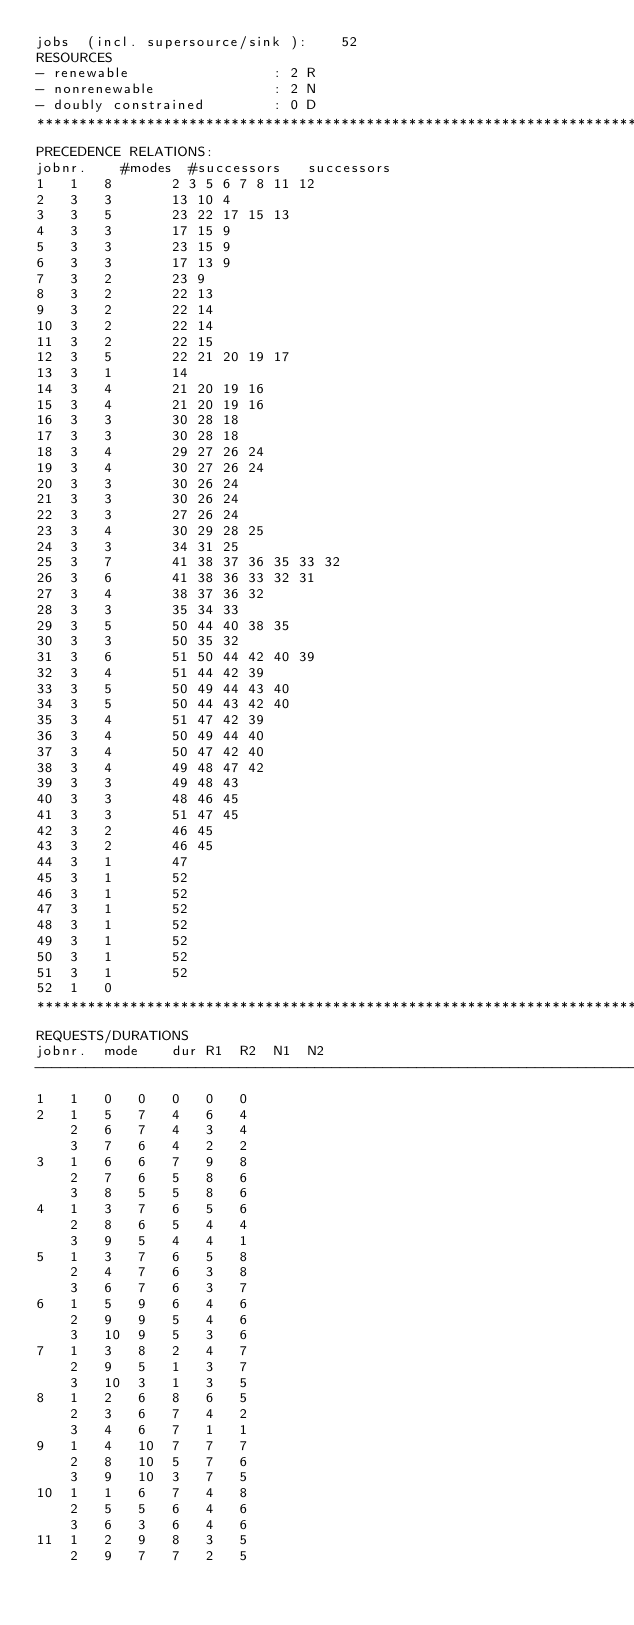Convert code to text. <code><loc_0><loc_0><loc_500><loc_500><_ObjectiveC_>jobs  (incl. supersource/sink ):	52
RESOURCES
- renewable                 : 2 R
- nonrenewable              : 2 N
- doubly constrained        : 0 D
************************************************************************
PRECEDENCE RELATIONS:
jobnr.    #modes  #successors   successors
1	1	8		2 3 5 6 7 8 11 12 
2	3	3		13 10 4 
3	3	5		23 22 17 15 13 
4	3	3		17 15 9 
5	3	3		23 15 9 
6	3	3		17 13 9 
7	3	2		23 9 
8	3	2		22 13 
9	3	2		22 14 
10	3	2		22 14 
11	3	2		22 15 
12	3	5		22 21 20 19 17 
13	3	1		14 
14	3	4		21 20 19 16 
15	3	4		21 20 19 16 
16	3	3		30 28 18 
17	3	3		30 28 18 
18	3	4		29 27 26 24 
19	3	4		30 27 26 24 
20	3	3		30 26 24 
21	3	3		30 26 24 
22	3	3		27 26 24 
23	3	4		30 29 28 25 
24	3	3		34 31 25 
25	3	7		41 38 37 36 35 33 32 
26	3	6		41 38 36 33 32 31 
27	3	4		38 37 36 32 
28	3	3		35 34 33 
29	3	5		50 44 40 38 35 
30	3	3		50 35 32 
31	3	6		51 50 44 42 40 39 
32	3	4		51 44 42 39 
33	3	5		50 49 44 43 40 
34	3	5		50 44 43 42 40 
35	3	4		51 47 42 39 
36	3	4		50 49 44 40 
37	3	4		50 47 42 40 
38	3	4		49 48 47 42 
39	3	3		49 48 43 
40	3	3		48 46 45 
41	3	3		51 47 45 
42	3	2		46 45 
43	3	2		46 45 
44	3	1		47 
45	3	1		52 
46	3	1		52 
47	3	1		52 
48	3	1		52 
49	3	1		52 
50	3	1		52 
51	3	1		52 
52	1	0		
************************************************************************
REQUESTS/DURATIONS
jobnr.	mode	dur	R1	R2	N1	N2	
------------------------------------------------------------------------
1	1	0	0	0	0	0	
2	1	5	7	4	6	4	
	2	6	7	4	3	4	
	3	7	6	4	2	2	
3	1	6	6	7	9	8	
	2	7	6	5	8	6	
	3	8	5	5	8	6	
4	1	3	7	6	5	6	
	2	8	6	5	4	4	
	3	9	5	4	4	1	
5	1	3	7	6	5	8	
	2	4	7	6	3	8	
	3	6	7	6	3	7	
6	1	5	9	6	4	6	
	2	9	9	5	4	6	
	3	10	9	5	3	6	
7	1	3	8	2	4	7	
	2	9	5	1	3	7	
	3	10	3	1	3	5	
8	1	2	6	8	6	5	
	2	3	6	7	4	2	
	3	4	6	7	1	1	
9	1	4	10	7	7	7	
	2	8	10	5	7	6	
	3	9	10	3	7	5	
10	1	1	6	7	4	8	
	2	5	5	6	4	6	
	3	6	3	6	4	6	
11	1	2	9	8	3	5	
	2	9	7	7	2	5	</code> 